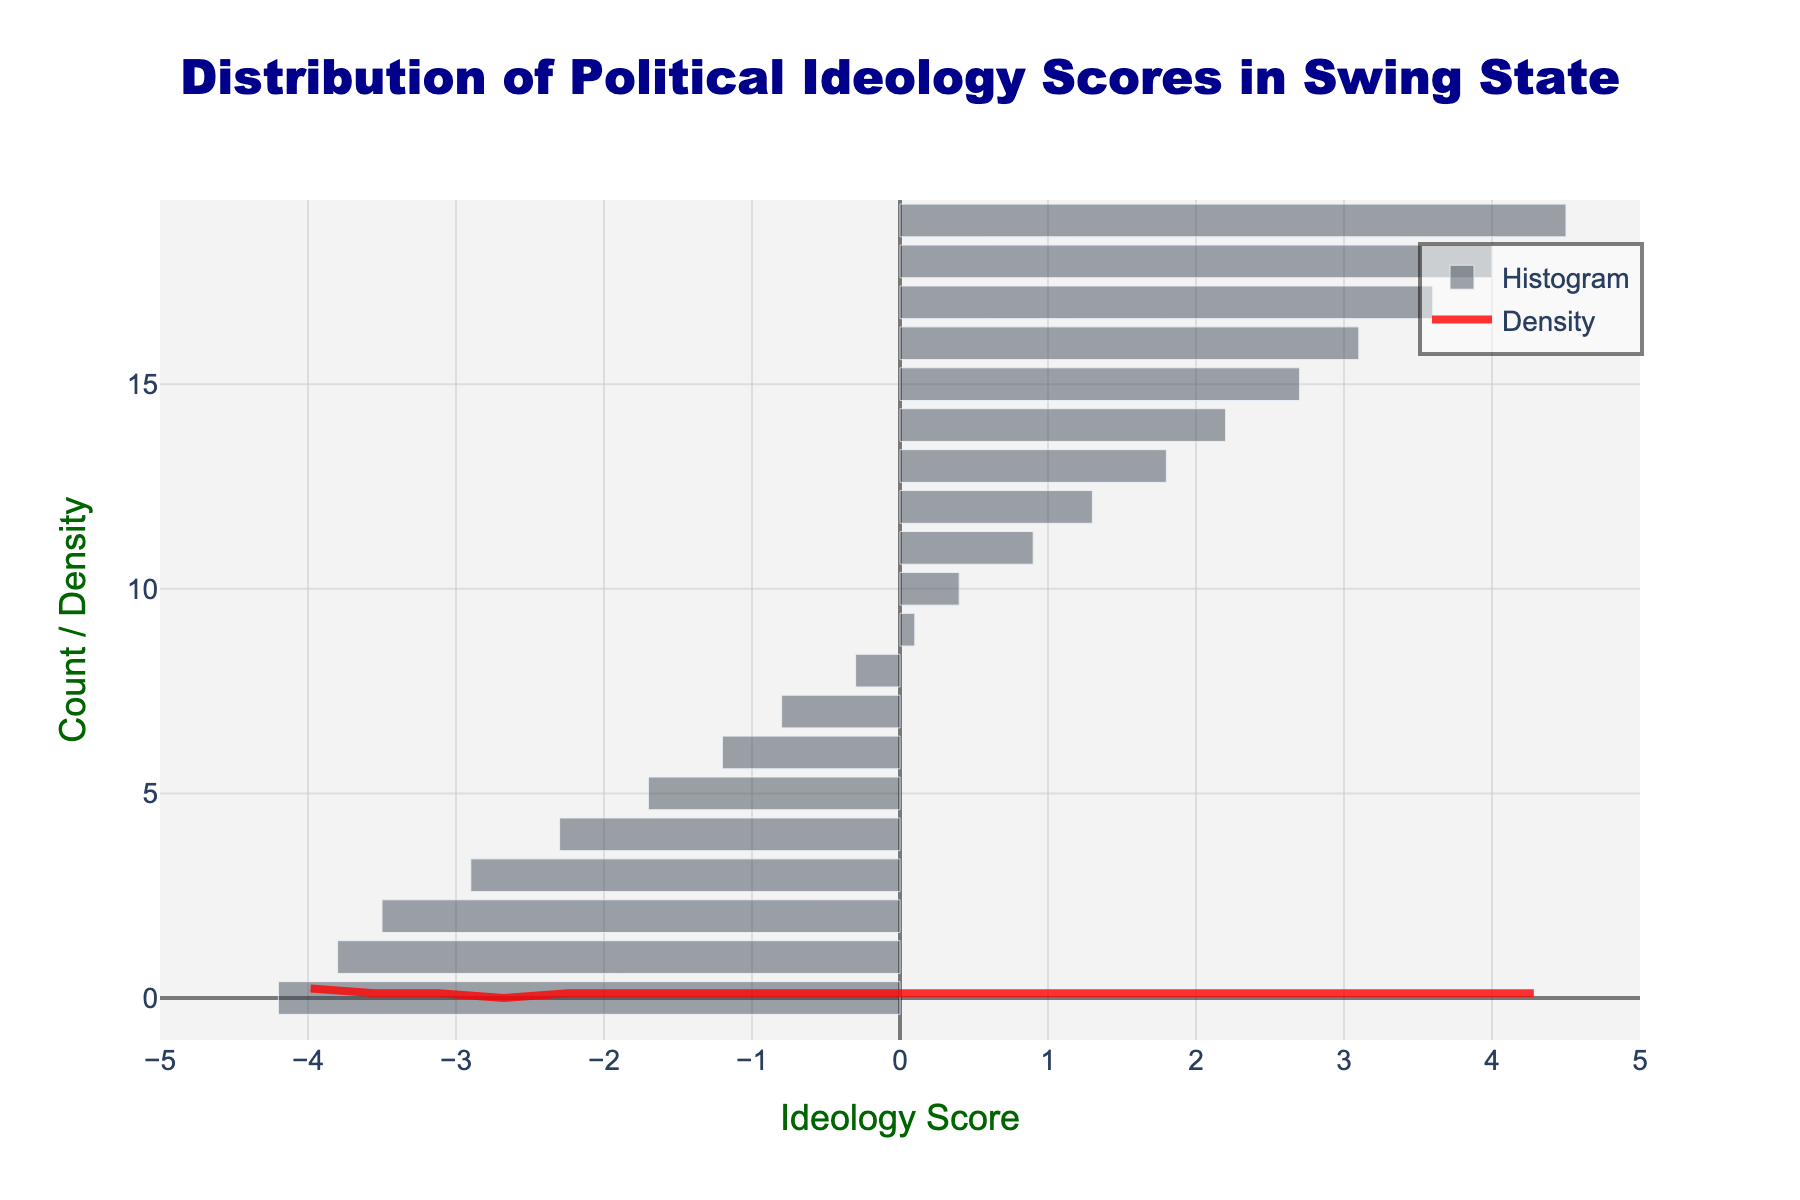What is the title of the figure? The title is located at the top center of the figure and is highlighted in dark blue and large font.
Answer: Distribution of Political Ideology Scores in Swing State What is the color of the KDE curve? The KDE curve is depicted as a line and is colored in a prominent bright shade.
Answer: Red How many ideology scores fall between -1 and 1? Count the number of bars (data points) in the histogram that are located between the scores -1 and 1 on the x-axis.
Answer: 5 Which ideology score has the highest density according to the KDE curve? Identify the peak of the KDE curve to determine which score corresponds to the highest density value.
Answer: Around -2.9 How does the count of extreme conservative (score > 3) and extreme liberal (score < -3) voters compare? Compare the number of bars to the right of score 3 to those to the left of score -3 on the x-axis.
Answer: The count for extreme conservative voters is higher What is the range of ideology scores shown on the x-axis? Identify the minimum and maximum values on the x-axis by looking at the ticks at both ends.
Answer: -5 to 5 What pattern can be observed in the distribution of political ideology scores? Describe the general trend observed from the histogram and KDE curve, like where data clusters or spreads.
Answer: The distribution is roughly centered around -2.9 with higher density in moderate to slightly liberal scores How does the density at score 4 compare to the density at score -4? Assess the height of the KDE curve at both x=4 and x=-4 and compare them.
Answer: The density at score 4 is lower than at score -4 What can you infer about the political orientation of the voters based on the histogram? Analyze the skewness and clustering on the histogram to interpret the overall political orientation tendency.
Answer: Voters are slightly skewed towards liberal ideology What is the total number of voters included in the data based on the histogram? Count the total number of bars in the histogram which corresponds to the total number of voters.
Answer: 20 